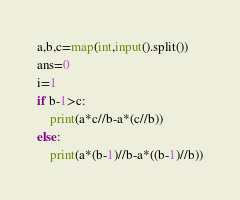<code> <loc_0><loc_0><loc_500><loc_500><_Python_>a,b,c=map(int,input().split())
ans=0
i=1
if b-1>c:
    print(a*c//b-a*(c//b))
else:
    print(a*(b-1)//b-a*((b-1)//b))</code> 